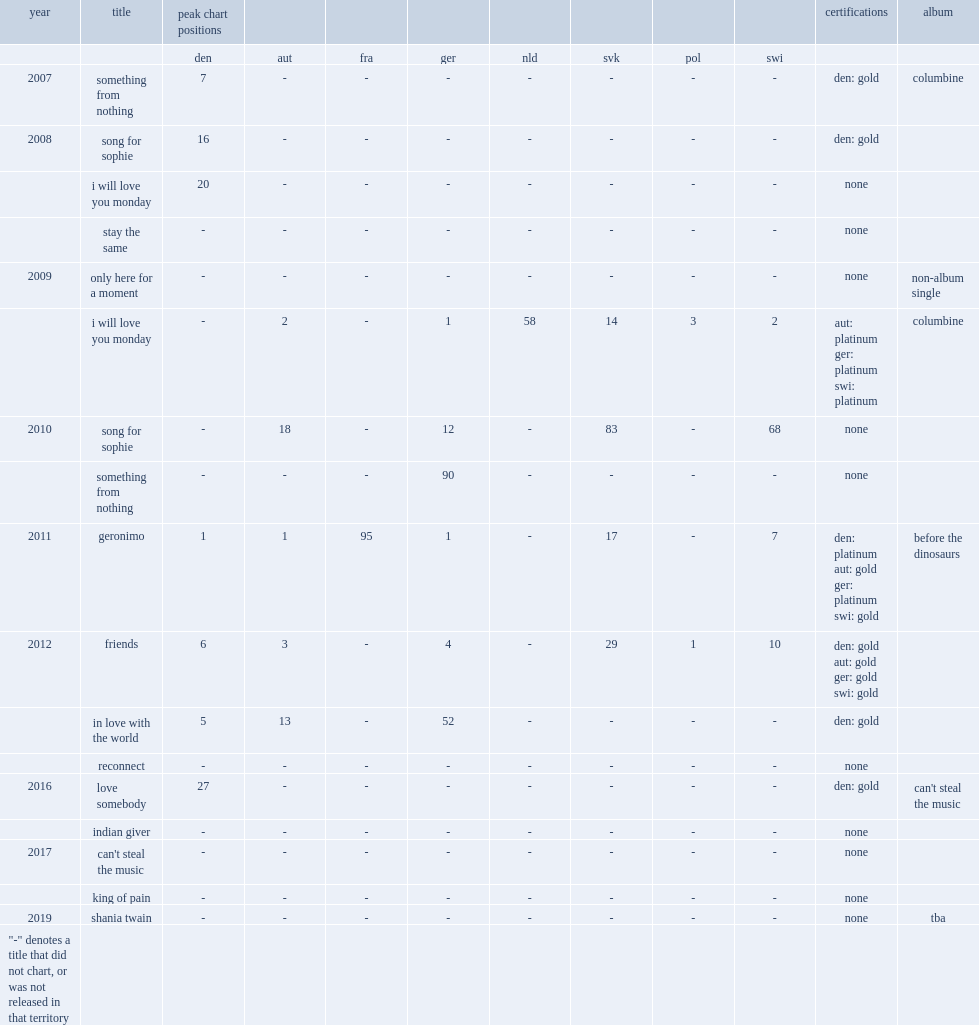What was the peak chart position in germany of the album "i will love you monday (365)"? 1.0. 